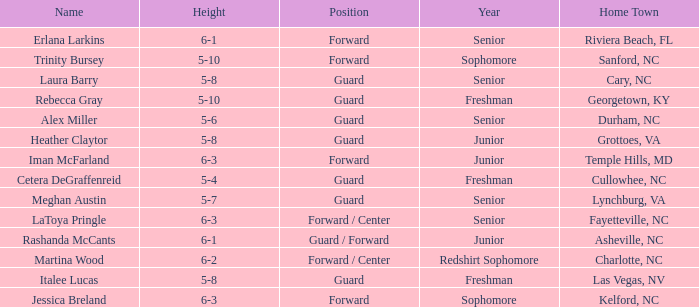What is the current school year for the forward iman mcfarland? Junior. 